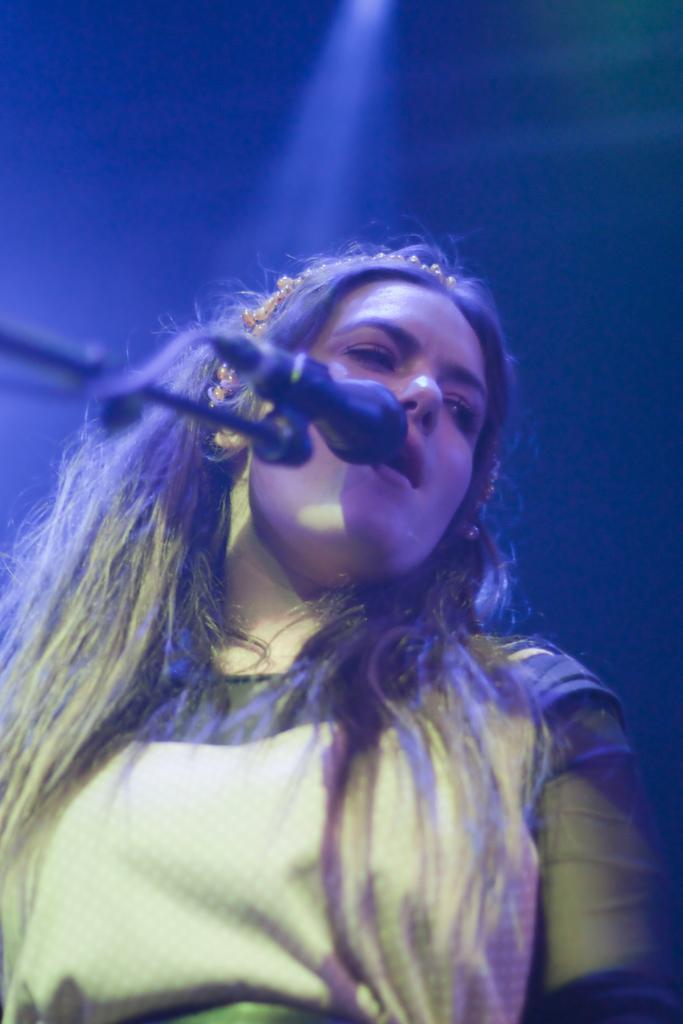Describe this image in one or two sentences. In this image a lady wearing yellow dress is singing. In front of her there is a mic. The background is dark. 